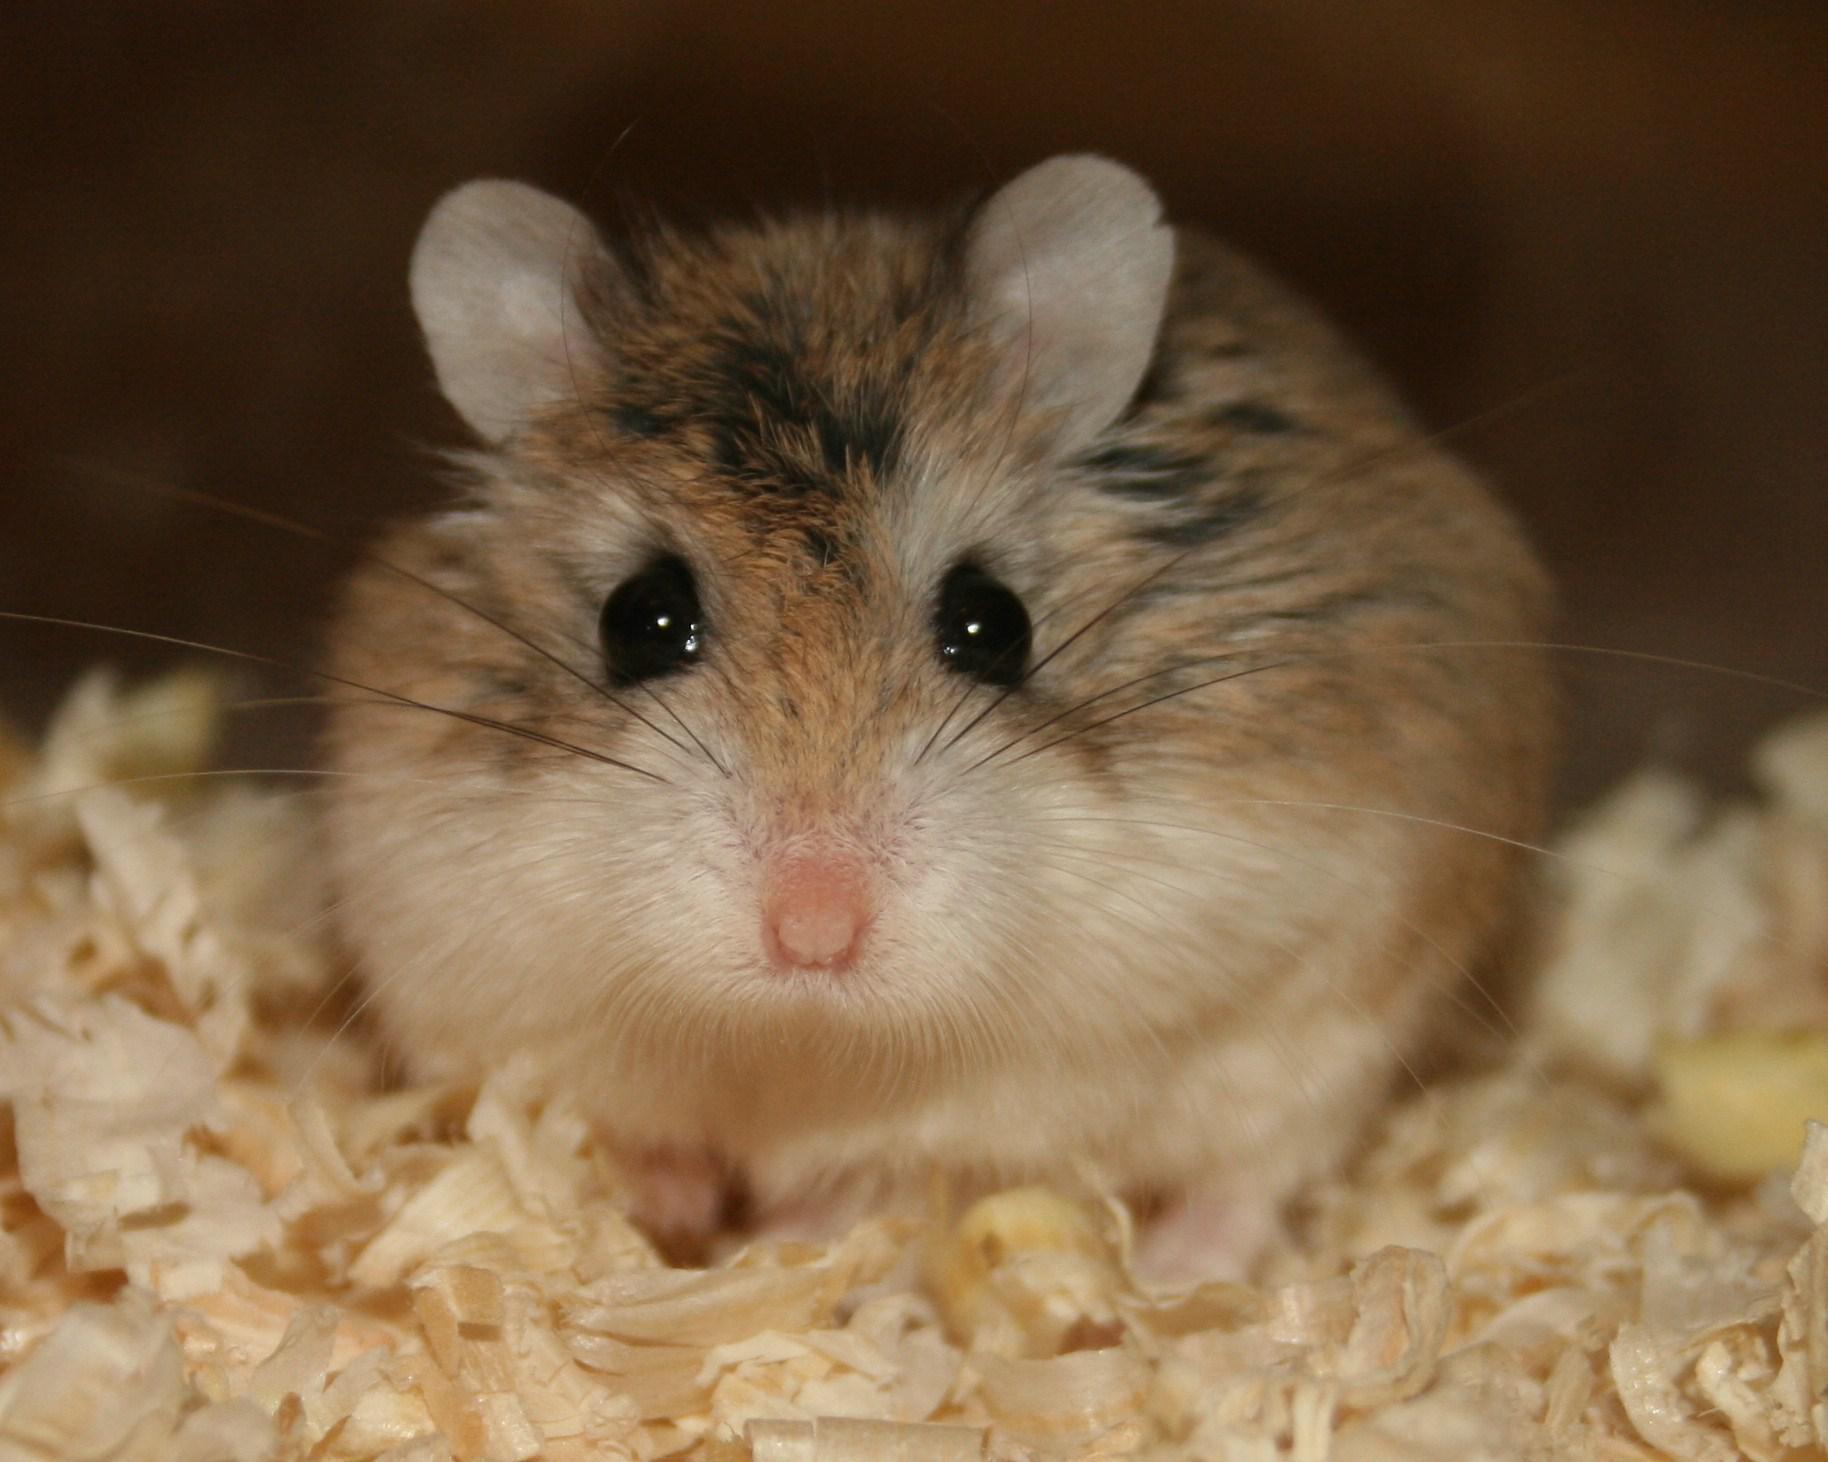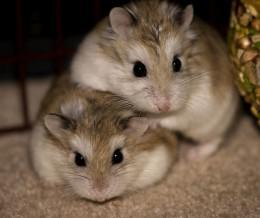The first image is the image on the left, the second image is the image on the right. Evaluate the accuracy of this statement regarding the images: "one animal is on top of the other in the right side image". Is it true? Answer yes or no. Yes. 